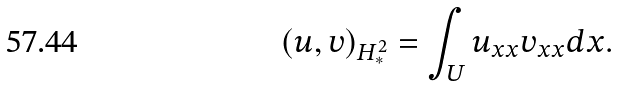<formula> <loc_0><loc_0><loc_500><loc_500>( u , v ) _ { H ^ { 2 } _ { * } } = \int _ { U } u _ { x x } v _ { x x } d x .</formula> 